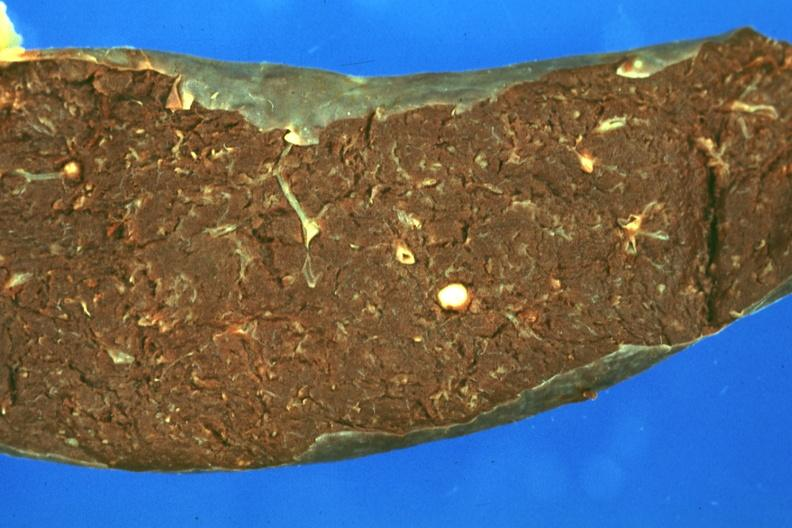s granuloma present?
Answer the question using a single word or phrase. Yes 